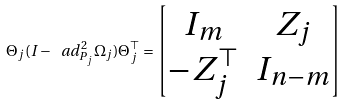<formula> <loc_0><loc_0><loc_500><loc_500>\Theta _ { j } ( I - \ a d _ { P _ { j } } ^ { 2 } \Omega _ { j } ) \Theta _ { j } ^ { \top } = \begin{bmatrix} I _ { m } & Z _ { j } \\ - Z _ { j } ^ { \top } & I _ { n - m } \end{bmatrix}</formula> 